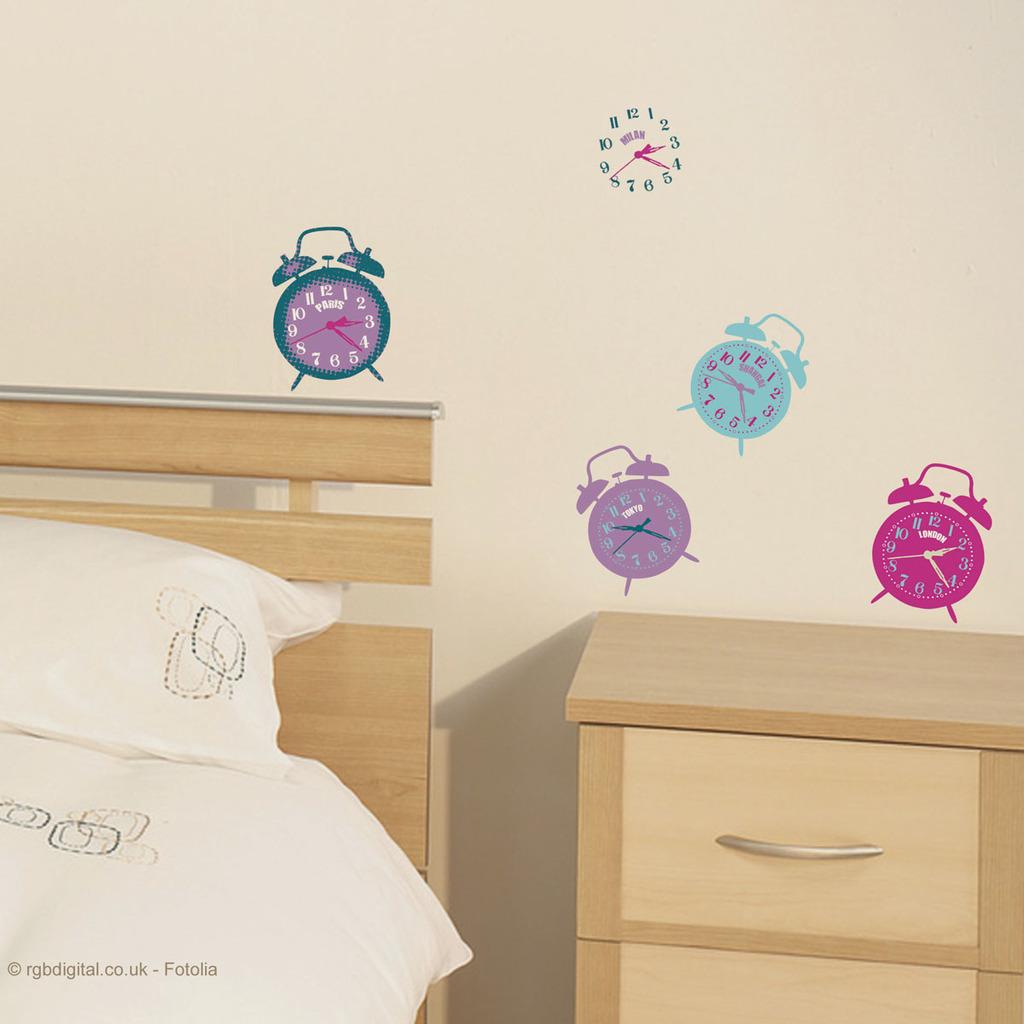What time does the purple clock read?
Provide a short and direct response. 10:25. What time does the pink clock read?
Your response must be concise. 2:20. 